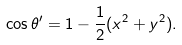<formula> <loc_0><loc_0><loc_500><loc_500>\cos \theta ^ { \prime } = 1 - \frac { 1 } { 2 } ( x ^ { 2 } + y ^ { 2 } ) .</formula> 